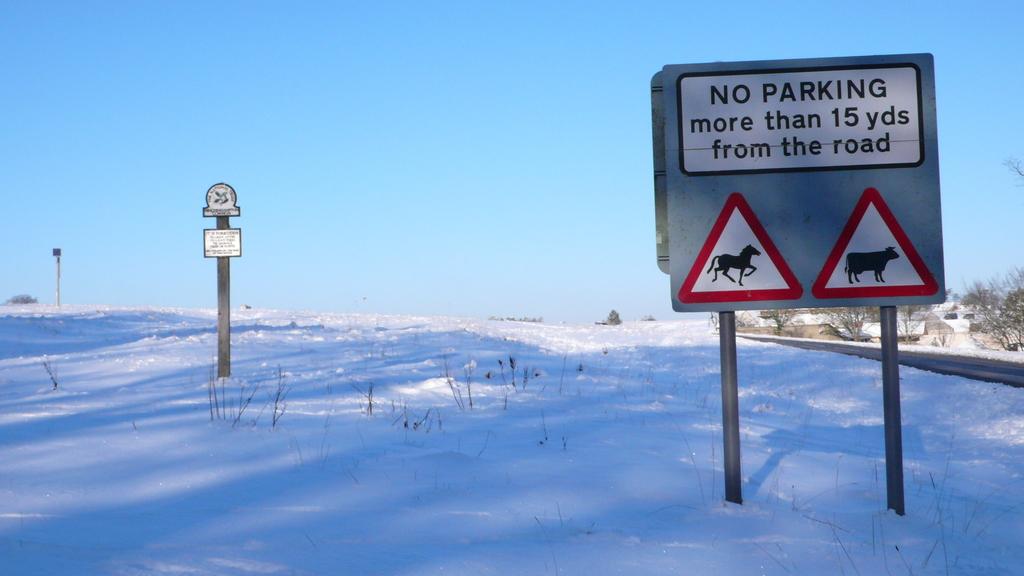How many yards from the yard is not parking?
Your response must be concise. 15. 